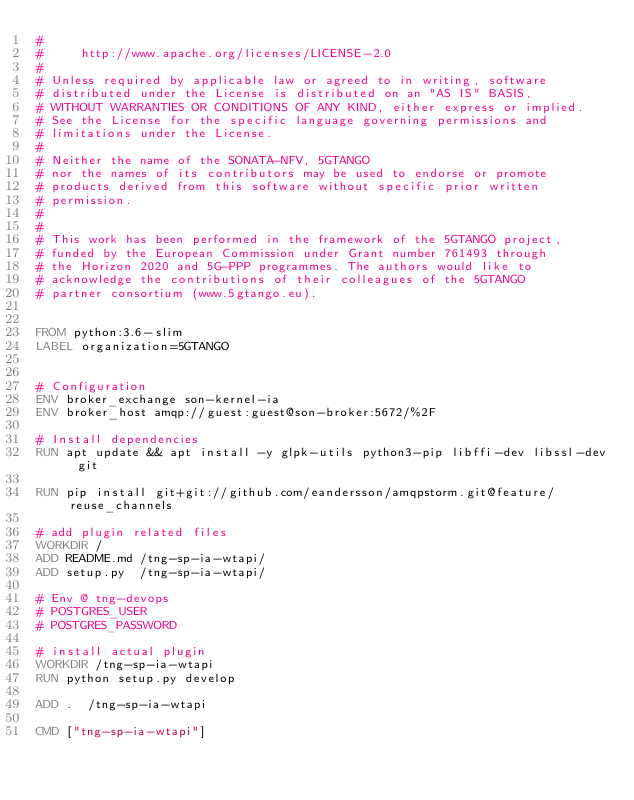Convert code to text. <code><loc_0><loc_0><loc_500><loc_500><_Dockerfile_>#
#     http://www.apache.org/licenses/LICENSE-2.0
#
# Unless required by applicable law or agreed to in writing, software
# distributed under the License is distributed on an "AS IS" BASIS,
# WITHOUT WARRANTIES OR CONDITIONS OF ANY KIND, either express or implied.
# See the License for the specific language governing permissions and
# limitations under the License.
#
# Neither the name of the SONATA-NFV, 5GTANGO
# nor the names of its contributors may be used to endorse or promote
# products derived from this software without specific prior written
# permission.
#
#
# This work has been performed in the framework of the 5GTANGO project,
# funded by the European Commission under Grant number 761493 through
# the Horizon 2020 and 5G-PPP programmes. The authors would like to
# acknowledge the contributions of their colleagues of the 5GTANGO
# partner consortium (www.5gtango.eu).


FROM python:3.6-slim
LABEL organization=5GTANGO


# Configuration
ENV broker_exchange son-kernel-ia
ENV broker_host amqp://guest:guest@son-broker:5672/%2F

# Install dependencies
RUN apt update && apt install -y glpk-utils python3-pip libffi-dev libssl-dev git

RUN pip install git+git://github.com/eandersson/amqpstorm.git@feature/reuse_channels

# add plugin related files
WORKDIR /
ADD README.md /tng-sp-ia-wtapi/
ADD setup.py  /tng-sp-ia-wtapi/

# Env @ tng-devops
# POSTGRES_USER
# POSTGRES_PASSWORD

# install actual plugin
WORKDIR /tng-sp-ia-wtapi
RUN python setup.py develop

ADD .  /tng-sp-ia-wtapi

CMD ["tng-sp-ia-wtapi"]
</code> 